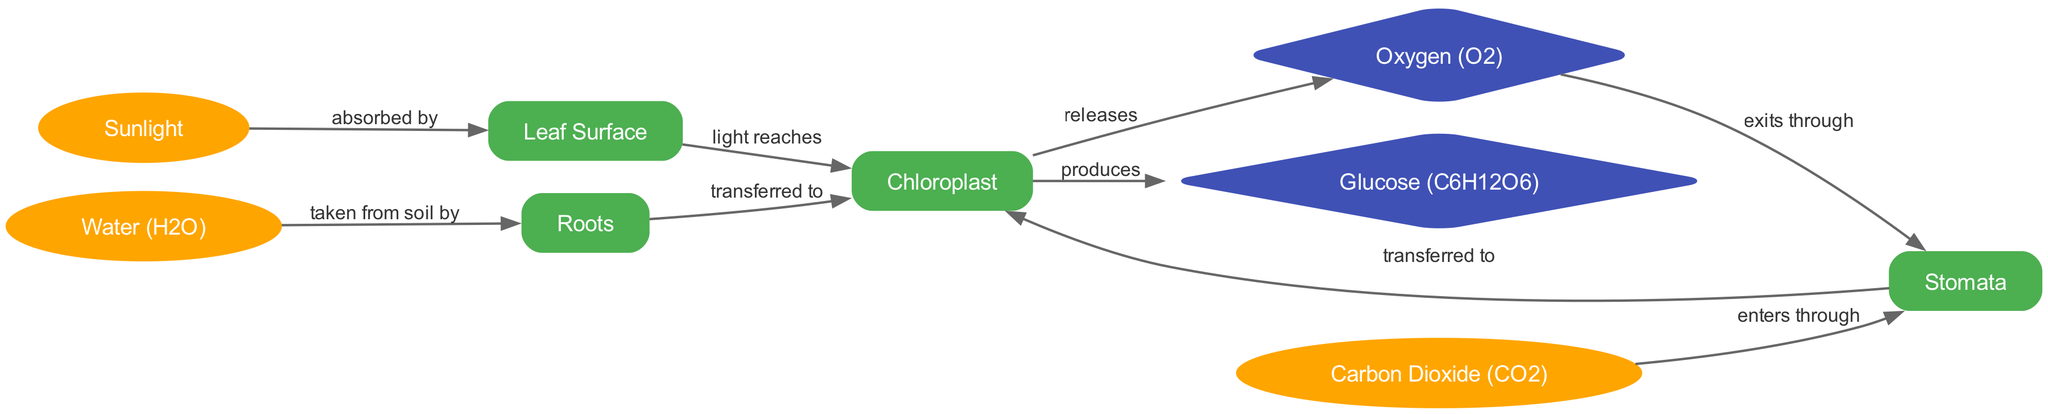What is the main product of the photosynthesis process? The main product of the photosynthesis process, as indicated in the diagram, is glucose, which is produced by the chloroplasts.
Answer: Glucose (C6H12O6) How many nodes are present in the diagram? By counting the distinct nodes in the diagram, there are nine nodes present that represent different components of the photosynthesis process.
Answer: 9 Where does water (H2O) come from in the diagram? According to the diagram, water (H2O) is taken from the soil by the roots, which then transfer it to the chloroplasts for photosynthesis.
Answer: Roots What do the stomata allow to enter the leaf structure? The diagram shows that the stomata allow carbon dioxide (CO2) to enter the leaf structure, as indicated by the flow from the stomata to the chloroplasts.
Answer: Carbon Dioxide (CO2) What are the two gases involved in the photosynthesis process? The diagram illustrates that oxygen (O2) is released by the chloroplasts and carbon dioxide (CO2) enters through the stomata, making these the two gases involved in the process.
Answer: Oxygen (O2) and Carbon Dioxide (CO2) What substance directly absorbs sunlight during photosynthesis? The diagram shows that sunlight is absorbed by the leaf surface, which allows the light to reach the chloroplasts, where photosynthesis occurs.
Answer: Leaf Surface From which part does the chloroplast produce glucose? Based on the diagram, the chloroplast produces glucose from the absorbed sunlight, water (H2O), and carbon dioxide (CO2) as inputs during the process of photosynthesis.
Answer: Chloroplast Which way does oxygen (O2) exit the leaf? The diagram indicates that oxygen (O2) exits the leaf through the stomata, as shown by the flow from the chloroplasts to the stomata.
Answer: Stomata What is the function of the chloroplast in photosynthesis? The chloroplast functions as the site of photosynthesis, where it produces glucose and releases oxygen as a byproduct using sunlight, water, and carbon dioxide.
Answer: Produces Glucose and Releases Oxygen 